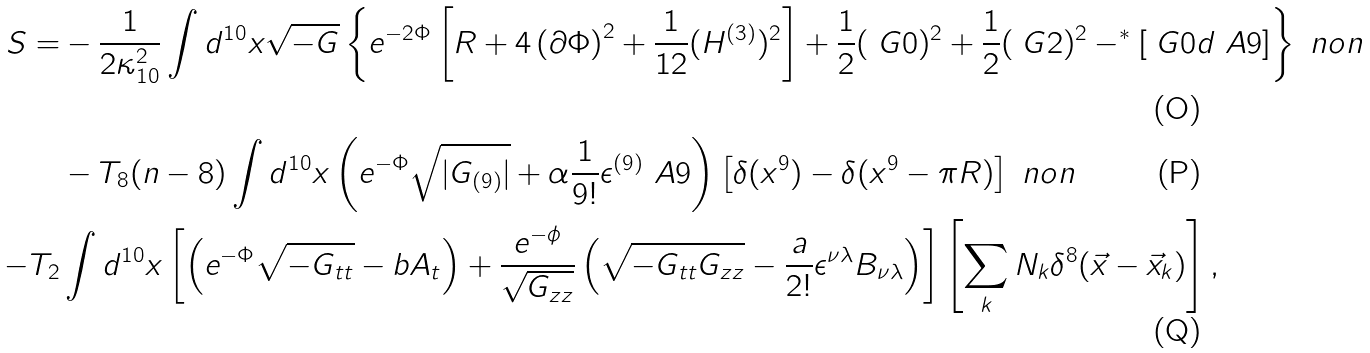<formula> <loc_0><loc_0><loc_500><loc_500>S = & - \frac { 1 } { 2 \kappa _ { 1 0 } ^ { 2 } } \int d ^ { 1 0 } x \sqrt { - G } \left \{ e ^ { - 2 \Phi } \left [ R + 4 \left ( \partial { \Phi } \right ) ^ { 2 } + \frac { 1 } { 1 2 } ( H ^ { ( 3 ) } ) ^ { 2 } \right ] + \frac { 1 } { 2 } ( \ G { 0 } ) ^ { 2 } + \frac { 1 } { 2 } ( \ G { 2 } ) ^ { 2 } - ^ { * } \left [ \ G { 0 } d \ A { 9 } \right ] \right \} \ n o n \\ & - T _ { 8 } ( n - 8 ) \int d ^ { 1 0 } x \left ( e ^ { - \Phi } \sqrt { | G _ { ( 9 ) } | } + \alpha \frac { 1 } { 9 ! } \epsilon ^ { ( 9 ) } \ A { 9 } \right ) \left [ \delta ( x ^ { 9 } ) - \delta ( x ^ { 9 } - \pi R ) \right ] \ n o n \\ - T _ { 2 } & \int d ^ { 1 0 } x \left [ \left ( e ^ { - \Phi } \sqrt { - G _ { t t } } - b A _ { t } \right ) + \frac { e ^ { - \phi } } { \sqrt { G _ { z z } } } \left ( \sqrt { - G _ { t t } G _ { z z } } - \frac { a } { 2 ! } \epsilon ^ { \nu \lambda } B _ { \nu \lambda } \right ) \right ] \left [ \sum _ { k } N _ { k } \delta ^ { 8 } ( \vec { x } - \vec { x } _ { k } ) \right ] ,</formula> 